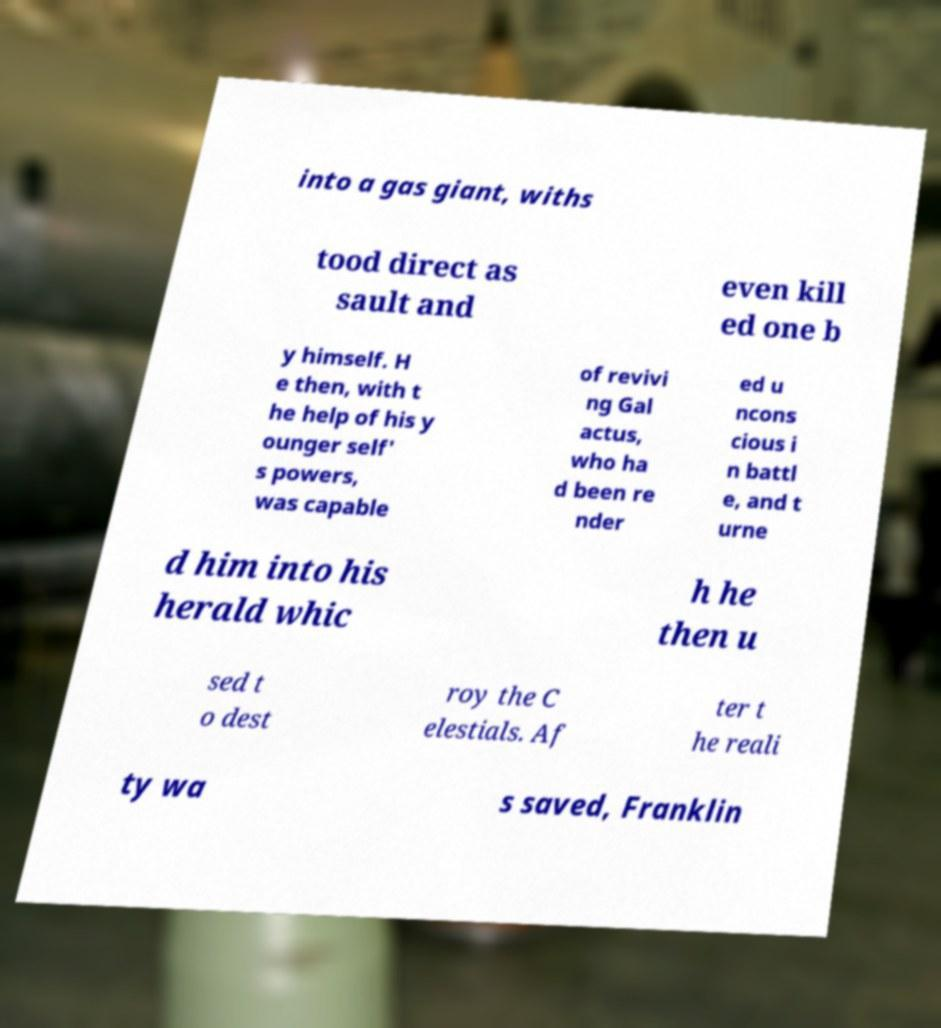I need the written content from this picture converted into text. Can you do that? into a gas giant, withs tood direct as sault and even kill ed one b y himself. H e then, with t he help of his y ounger self' s powers, was capable of revivi ng Gal actus, who ha d been re nder ed u ncons cious i n battl e, and t urne d him into his herald whic h he then u sed t o dest roy the C elestials. Af ter t he reali ty wa s saved, Franklin 